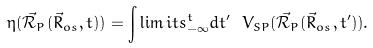Convert formula to latex. <formula><loc_0><loc_0><loc_500><loc_500>\eta ( \mathcal { \vec { R } } _ { P } ( \vec { R } _ { o s } , t ) ) = \int \lim i t s _ { - \infty } ^ { t } d t ^ { \prime } \ V _ { S P } ( \mathcal { \vec { R } } _ { P } ( \vec { R } _ { o s } , t ^ { \prime } ) ) .</formula> 